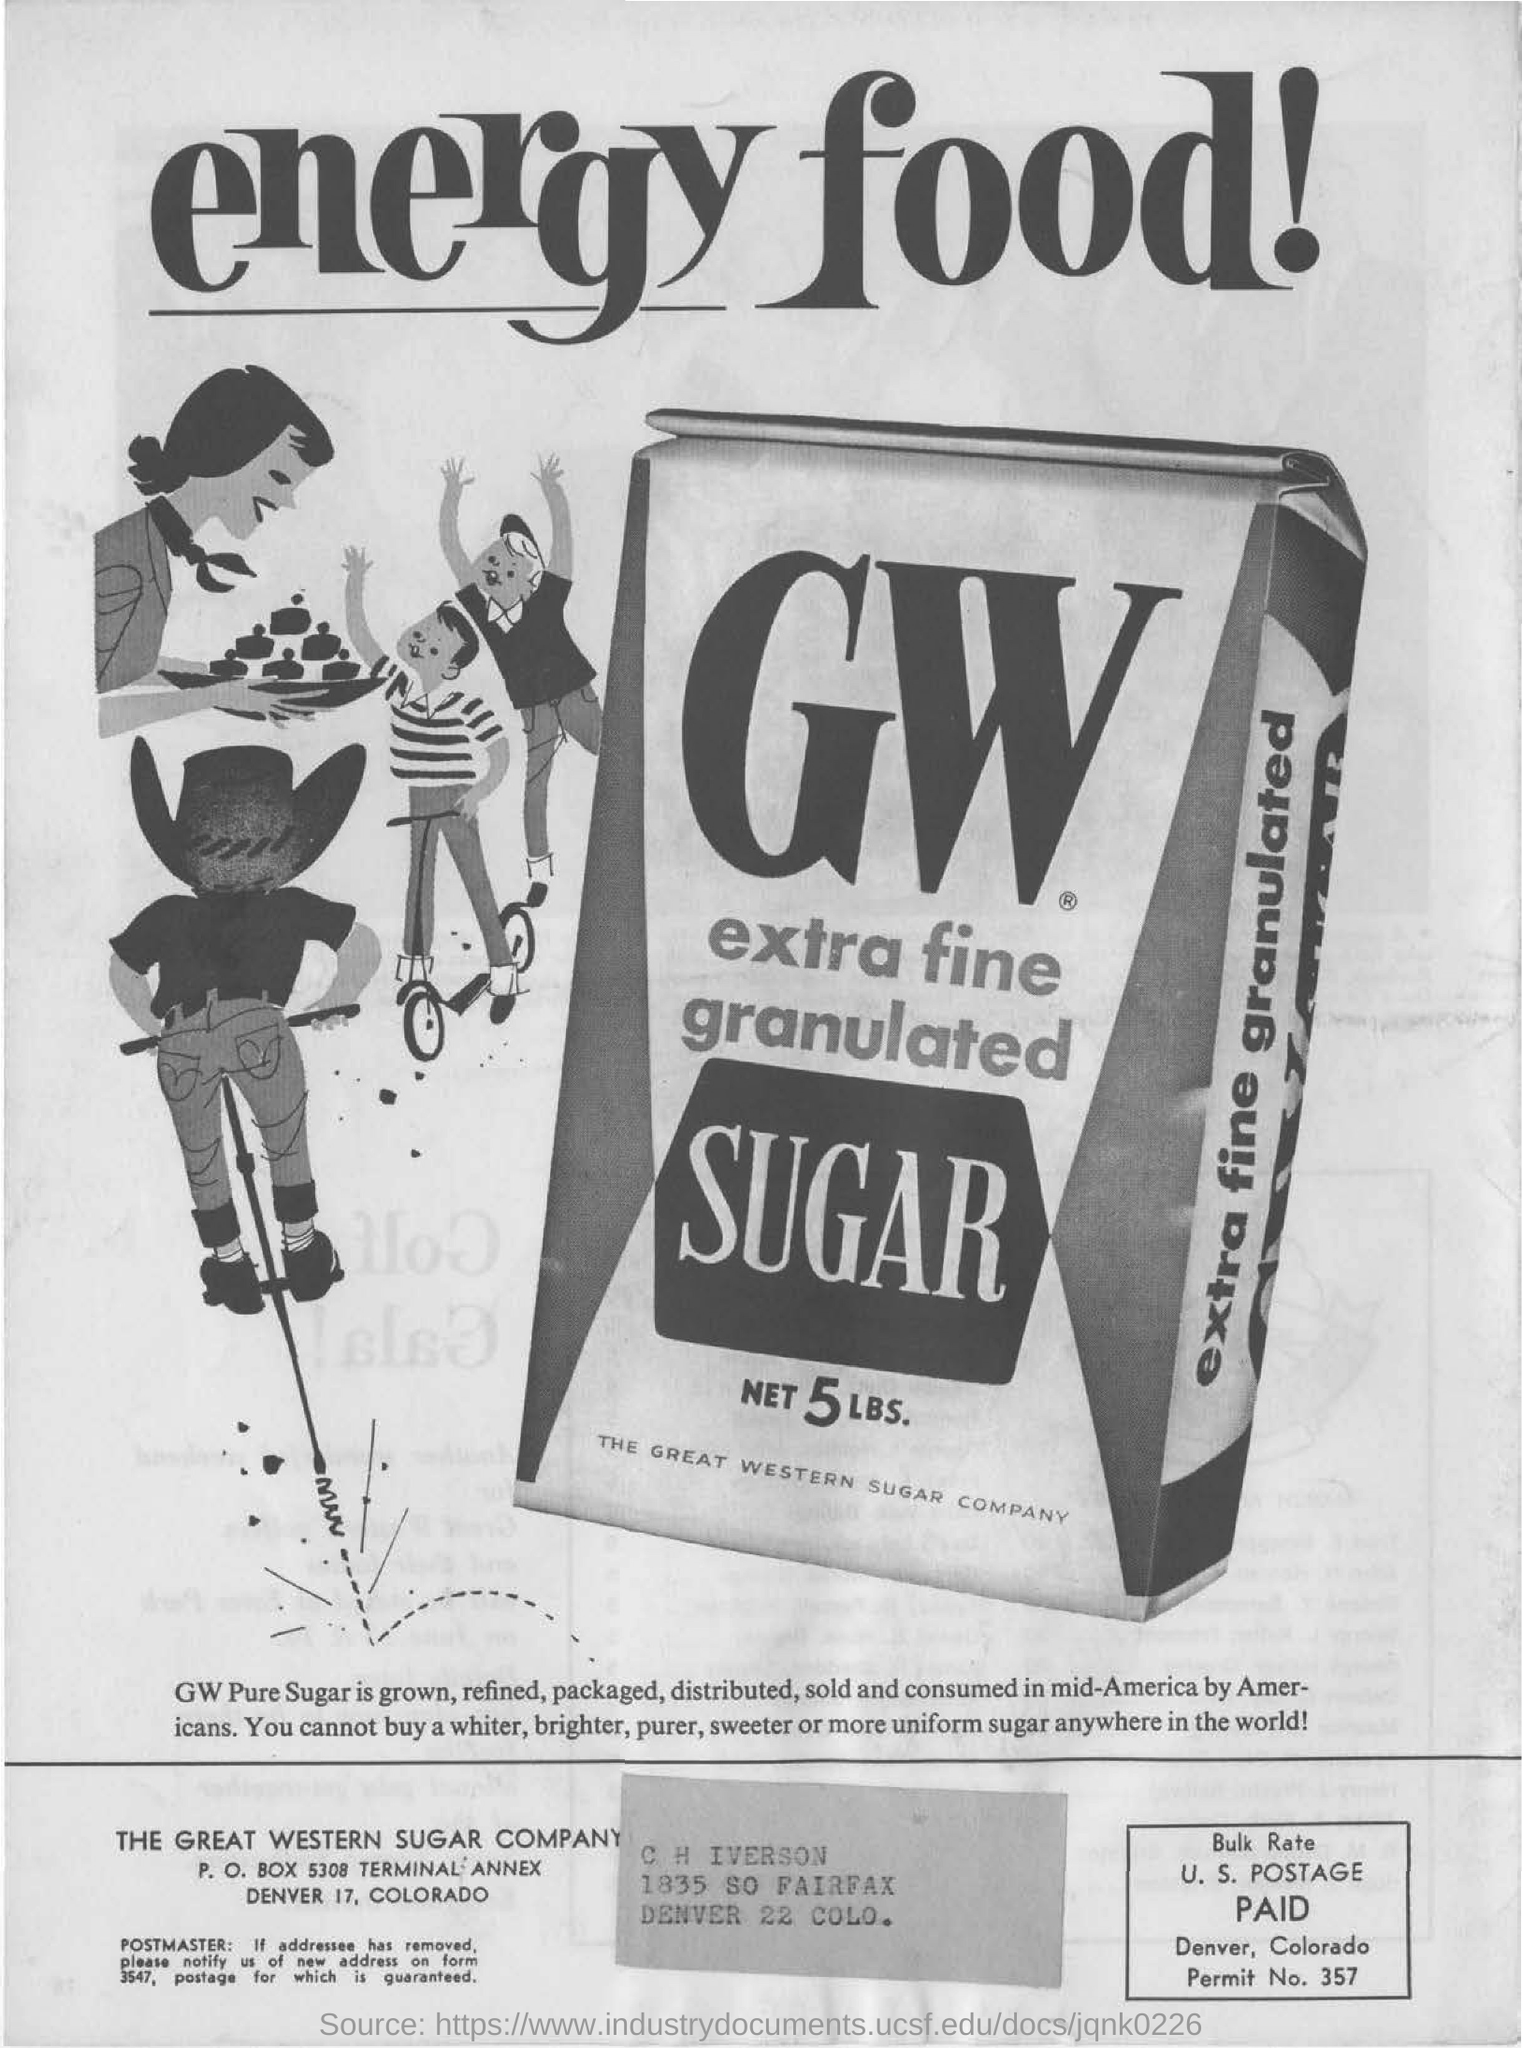Draw attention to some important aspects in this diagram. Declarative Sentence: What is image advertising? GW Extra Fine Granulated Sugar is an example of this type of advertising. The net amount of sugar is 5 pounds. 